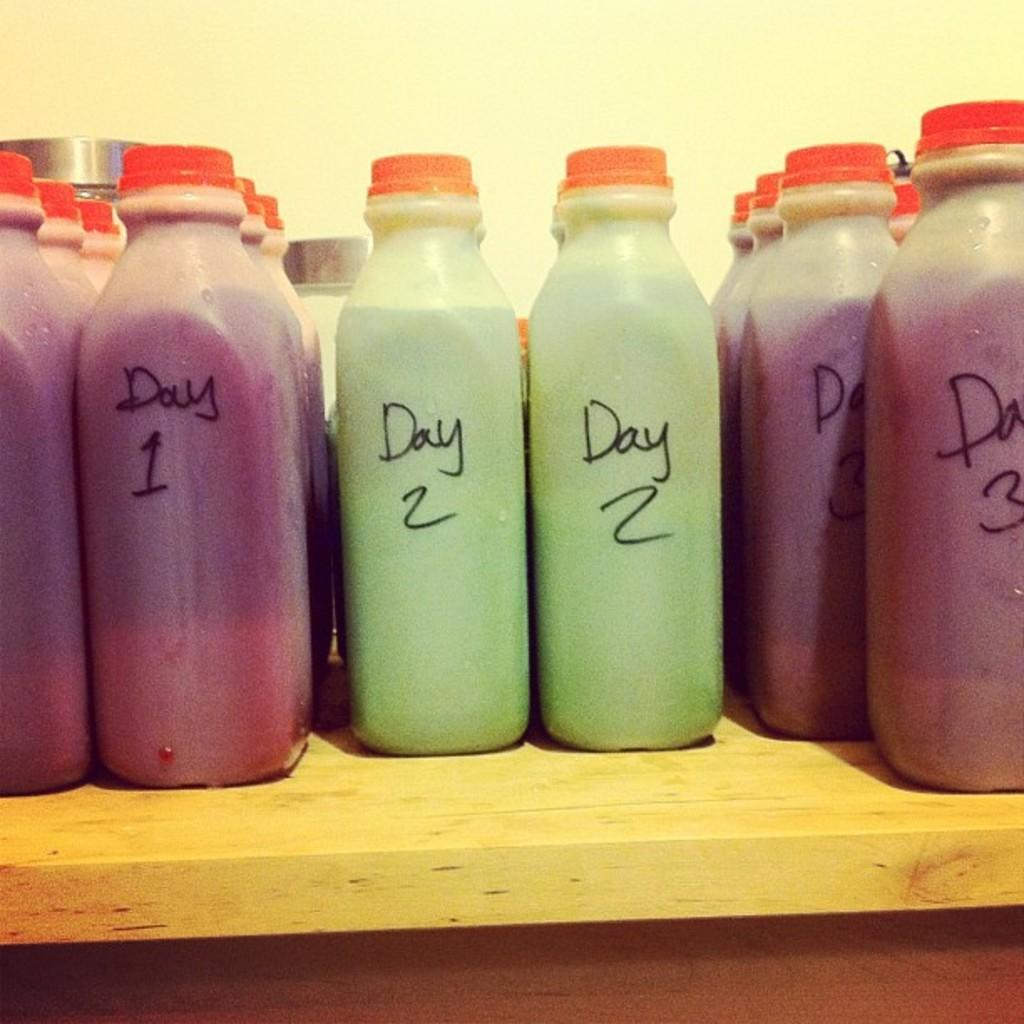What type of containers are visible in the image? There are bottles with lids in the image. What is inside the bottles? The bottles are filled with liquid. Where are the bottles placed? The bottles are placed on a wooden table. What can be seen in the background of the image? There is a white wall in the background of the image. How many heads of lettuce can be seen on the table in the image? There are no heads of lettuce present in the image; it only features bottles with lids on a wooden table. 